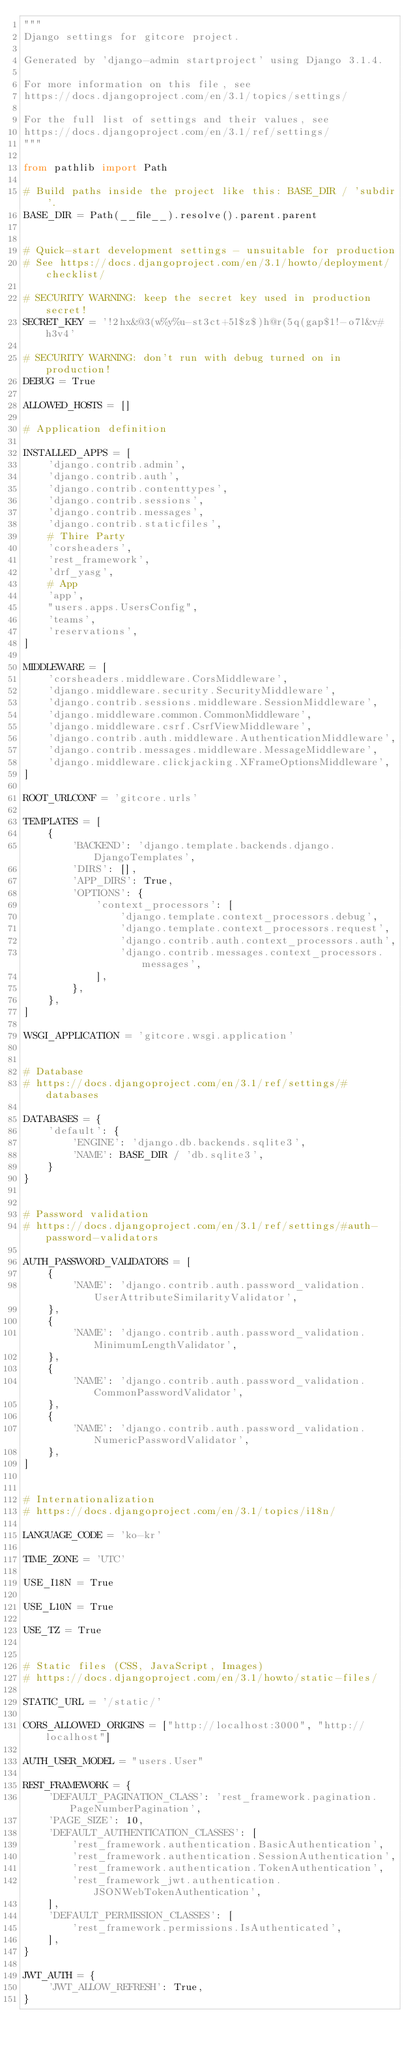Convert code to text. <code><loc_0><loc_0><loc_500><loc_500><_Python_>"""
Django settings for gitcore project.

Generated by 'django-admin startproject' using Django 3.1.4.

For more information on this file, see
https://docs.djangoproject.com/en/3.1/topics/settings/

For the full list of settings and their values, see
https://docs.djangoproject.com/en/3.1/ref/settings/
"""

from pathlib import Path

# Build paths inside the project like this: BASE_DIR / 'subdir'.
BASE_DIR = Path(__file__).resolve().parent.parent


# Quick-start development settings - unsuitable for production
# See https://docs.djangoproject.com/en/3.1/howto/deployment/checklist/

# SECURITY WARNING: keep the secret key used in production secret!
SECRET_KEY = '!2hx&@3(w%y%u-st3ct+5l$z$)h@r(5q(gap$1!-o7l&v#h3v4'

# SECURITY WARNING: don't run with debug turned on in production!
DEBUG = True

ALLOWED_HOSTS = []

# Application definition

INSTALLED_APPS = [
    'django.contrib.admin',
    'django.contrib.auth',
    'django.contrib.contenttypes',
    'django.contrib.sessions',
    'django.contrib.messages',
    'django.contrib.staticfiles',
    # Thire Party
    'corsheaders',
    'rest_framework',
    'drf_yasg',
    # App
    'app',
    "users.apps.UsersConfig",
    'teams',
    'reservations',
]

MIDDLEWARE = [
    'corsheaders.middleware.CorsMiddleware',
    'django.middleware.security.SecurityMiddleware',
    'django.contrib.sessions.middleware.SessionMiddleware',
    'django.middleware.common.CommonMiddleware',
    'django.middleware.csrf.CsrfViewMiddleware',
    'django.contrib.auth.middleware.AuthenticationMiddleware',
    'django.contrib.messages.middleware.MessageMiddleware',
    'django.middleware.clickjacking.XFrameOptionsMiddleware',
]

ROOT_URLCONF = 'gitcore.urls'

TEMPLATES = [
    {
        'BACKEND': 'django.template.backends.django.DjangoTemplates',
        'DIRS': [],
        'APP_DIRS': True,
        'OPTIONS': {
            'context_processors': [
                'django.template.context_processors.debug',
                'django.template.context_processors.request',
                'django.contrib.auth.context_processors.auth',
                'django.contrib.messages.context_processors.messages',
            ],
        },
    },
]

WSGI_APPLICATION = 'gitcore.wsgi.application'


# Database
# https://docs.djangoproject.com/en/3.1/ref/settings/#databases

DATABASES = {
    'default': {
        'ENGINE': 'django.db.backends.sqlite3',
        'NAME': BASE_DIR / 'db.sqlite3',
    }
}


# Password validation
# https://docs.djangoproject.com/en/3.1/ref/settings/#auth-password-validators

AUTH_PASSWORD_VALIDATORS = [
    {
        'NAME': 'django.contrib.auth.password_validation.UserAttributeSimilarityValidator',
    },
    {
        'NAME': 'django.contrib.auth.password_validation.MinimumLengthValidator',
    },
    {
        'NAME': 'django.contrib.auth.password_validation.CommonPasswordValidator',
    },
    {
        'NAME': 'django.contrib.auth.password_validation.NumericPasswordValidator',
    },
]


# Internationalization
# https://docs.djangoproject.com/en/3.1/topics/i18n/

LANGUAGE_CODE = 'ko-kr'

TIME_ZONE = 'UTC'

USE_I18N = True

USE_L10N = True

USE_TZ = True


# Static files (CSS, JavaScript, Images)
# https://docs.djangoproject.com/en/3.1/howto/static-files/

STATIC_URL = '/static/'

CORS_ALLOWED_ORIGINS = ["http://localhost:3000", "http://localhost"]

AUTH_USER_MODEL = "users.User"

REST_FRAMEWORK = {
    'DEFAULT_PAGINATION_CLASS': 'rest_framework.pagination.PageNumberPagination',
    'PAGE_SIZE': 10,
    'DEFAULT_AUTHENTICATION_CLASSES': [
        'rest_framework.authentication.BasicAuthentication',
        'rest_framework.authentication.SessionAuthentication',
        'rest_framework.authentication.TokenAuthentication',
        'rest_framework_jwt.authentication.JSONWebTokenAuthentication',
    ],
    'DEFAULT_PERMISSION_CLASSES': [
        'rest_framework.permissions.IsAuthenticated',
    ],
}

JWT_AUTH = {
    'JWT_ALLOW_REFRESH': True,
}</code> 